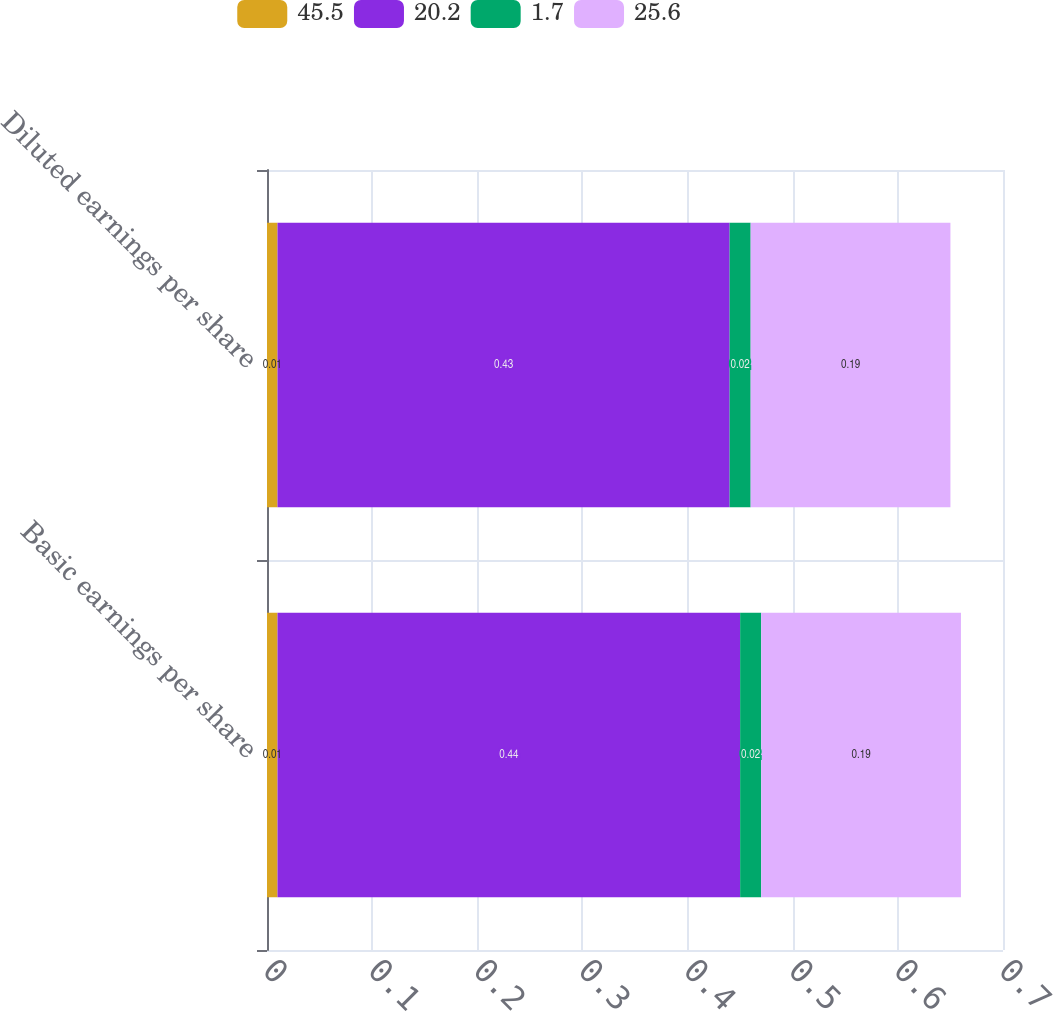<chart> <loc_0><loc_0><loc_500><loc_500><stacked_bar_chart><ecel><fcel>Basic earnings per share<fcel>Diluted earnings per share<nl><fcel>45.5<fcel>0.01<fcel>0.01<nl><fcel>20.2<fcel>0.44<fcel>0.43<nl><fcel>1.7<fcel>0.02<fcel>0.02<nl><fcel>25.6<fcel>0.19<fcel>0.19<nl></chart> 